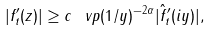<formula> <loc_0><loc_0><loc_500><loc_500>| f _ { t } ^ { \prime } ( z ) | \geq c \, \ v p ( 1 / y ) ^ { - 2 \alpha } | \hat { f } ^ { \prime } _ { t } ( i y ) | ,</formula> 